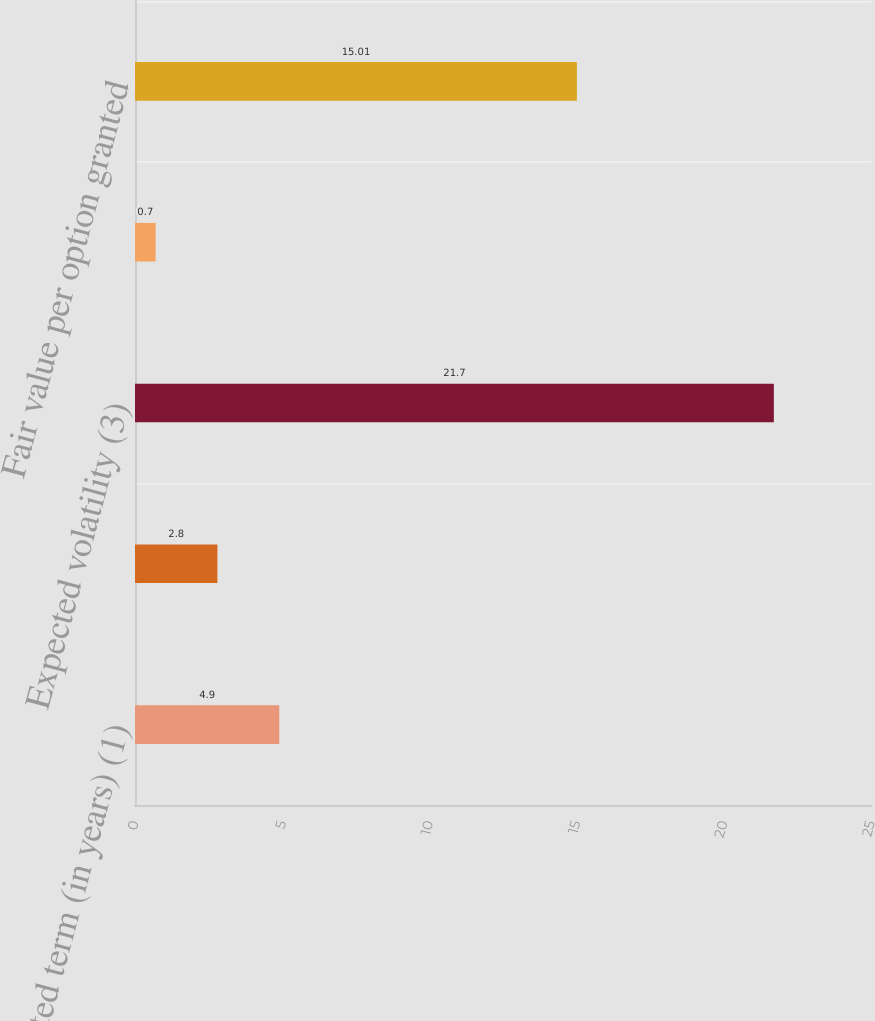Convert chart to OTSL. <chart><loc_0><loc_0><loc_500><loc_500><bar_chart><fcel>Expected term (in years) (1)<fcel>Risk-free rate of return (2)<fcel>Expected volatility (3)<fcel>Expected dividend yield (4)<fcel>Fair value per option granted<nl><fcel>4.9<fcel>2.8<fcel>21.7<fcel>0.7<fcel>15.01<nl></chart> 